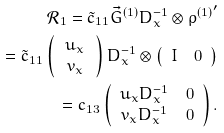<formula> <loc_0><loc_0><loc_500><loc_500>\mathcal { R } _ { 1 } = \tilde { c } _ { 1 1 } \vec { G } ^ { ( 1 ) } D _ { x } ^ { - 1 } \otimes { \rho ^ { ( 1 ) } } ^ { \prime } \\ = \tilde { c } _ { 1 1 } \left ( \, \begin{array} { c } u _ { x } \\ v _ { x } \end{array} \, \right ) D _ { x } ^ { - 1 } \otimes \left ( \begin{array} { c c } I & 0 \end{array} \right ) \\ = c _ { 1 3 } \left ( \begin{array} { c c } u _ { x } D _ { x } ^ { - 1 } & 0 \\ v _ { x } D _ { x } ^ { - 1 } & 0 \end{array} \right ) .</formula> 